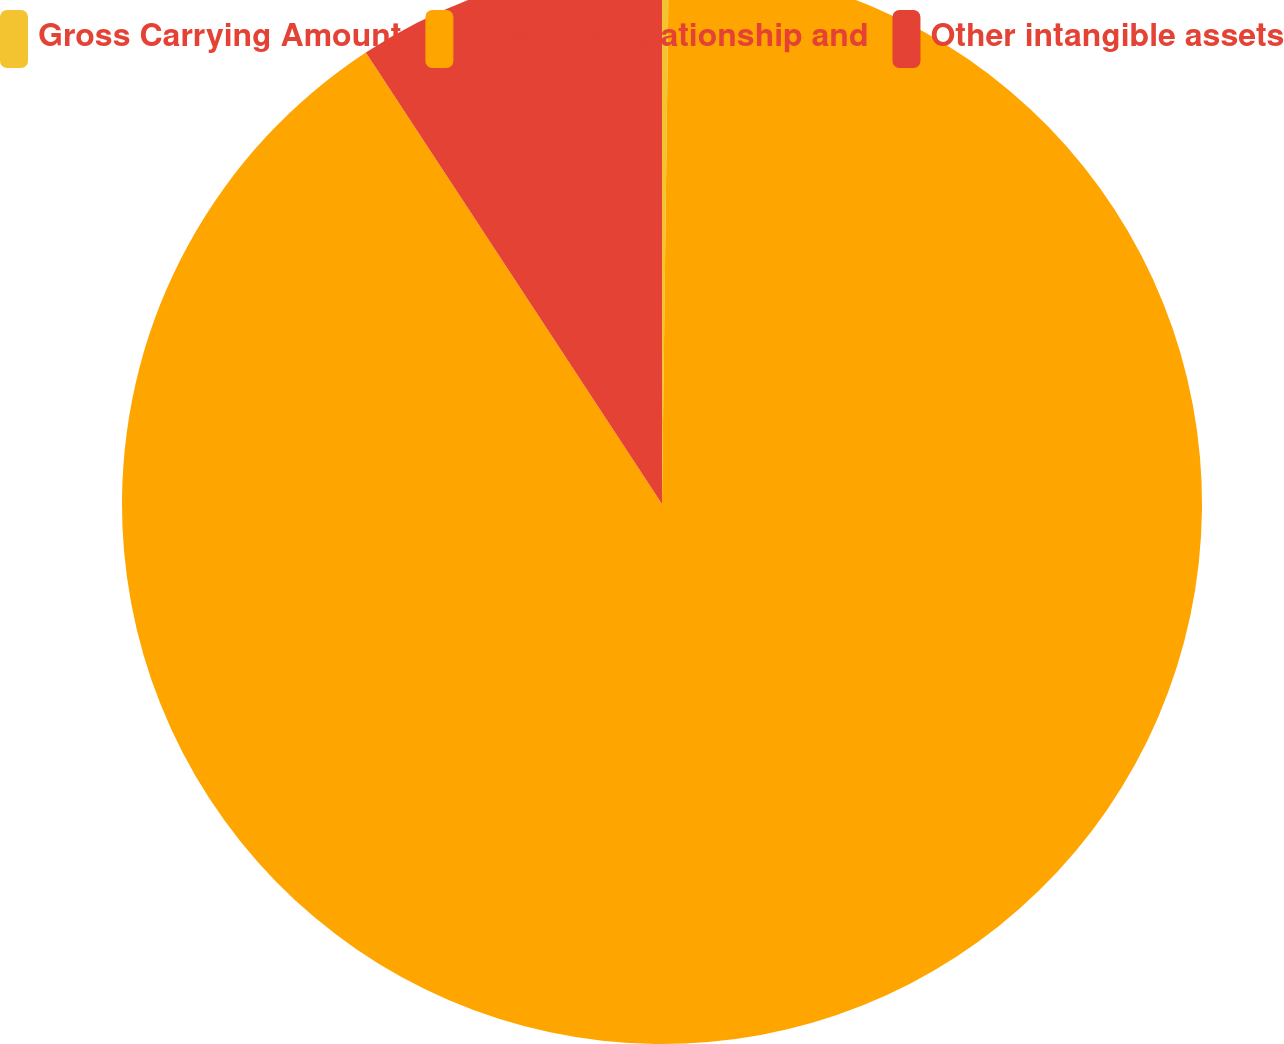Convert chart. <chart><loc_0><loc_0><loc_500><loc_500><pie_chart><fcel>Gross Carrying Amount<fcel>Customer relationship and<fcel>Other intangible assets<nl><fcel>0.2%<fcel>90.56%<fcel>9.24%<nl></chart> 